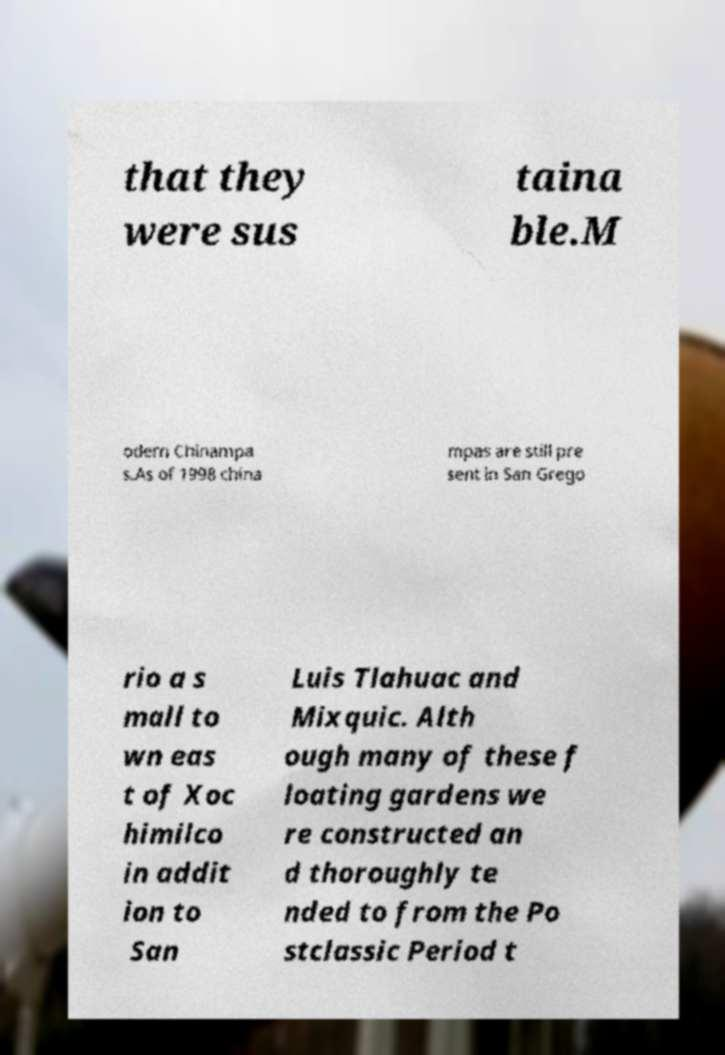What messages or text are displayed in this image? I need them in a readable, typed format. that they were sus taina ble.M odern Chinampa s.As of 1998 china mpas are still pre sent in San Grego rio a s mall to wn eas t of Xoc himilco in addit ion to San Luis Tlahuac and Mixquic. Alth ough many of these f loating gardens we re constructed an d thoroughly te nded to from the Po stclassic Period t 